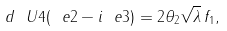<formula> <loc_0><loc_0><loc_500><loc_500>d \ U 4 ( \ e 2 - i \ e 3 ) = 2 \theta _ { 2 } \sqrt { \lambda } \, f _ { 1 } ,</formula> 